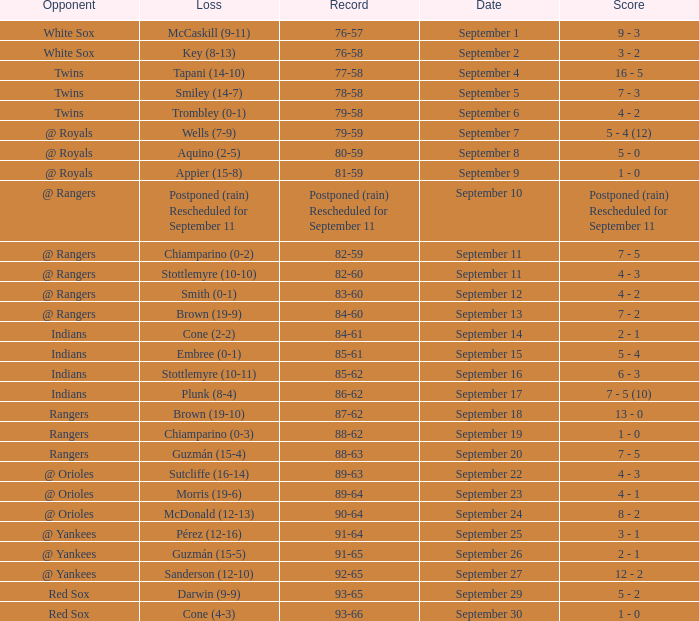What opponent has a record of 86-62? Indians. 